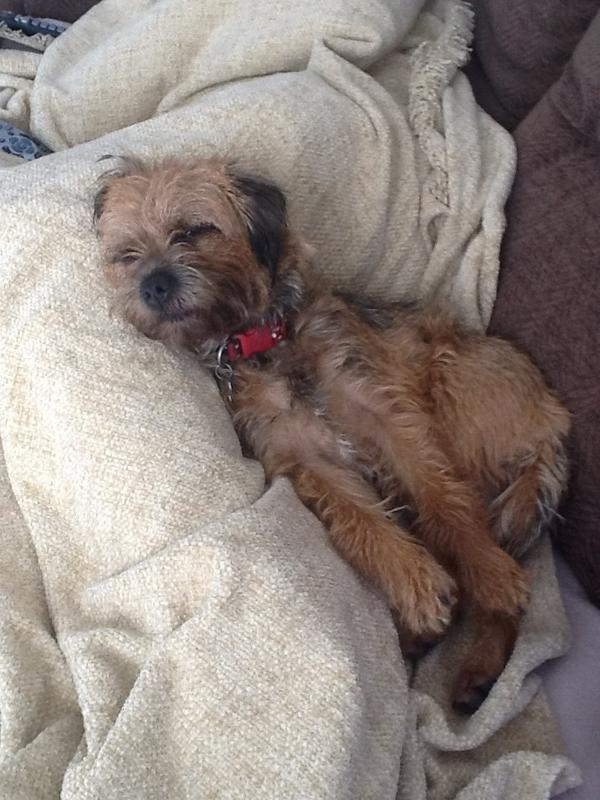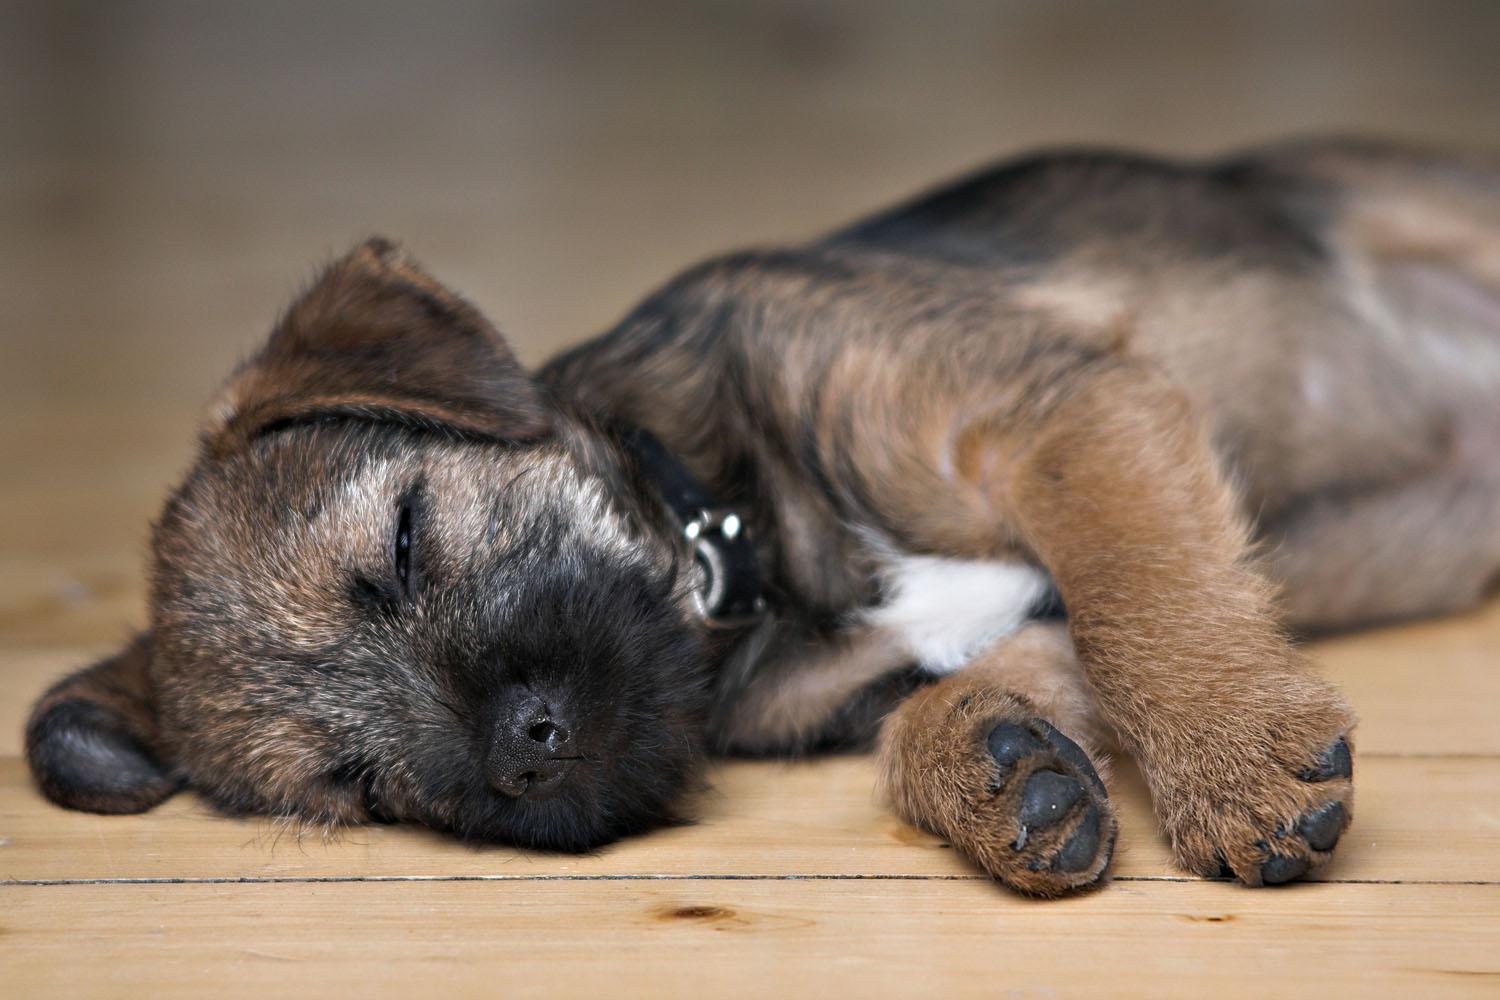The first image is the image on the left, the second image is the image on the right. Examine the images to the left and right. Is the description "One dog is sleeping directly on a hard, wood-look floor." accurate? Answer yes or no. Yes. The first image is the image on the left, the second image is the image on the right. For the images shown, is this caption "A puppy is asleep on a wooden floor." true? Answer yes or no. Yes. 